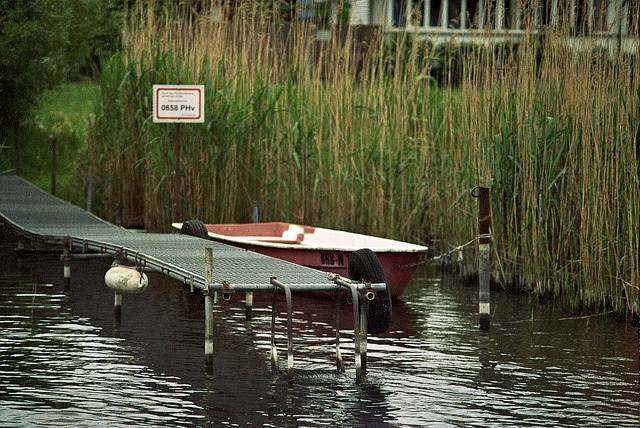Describe the objects in this image and their specific colors. I can see a boat in black, white, maroon, and salmon tones in this image. 